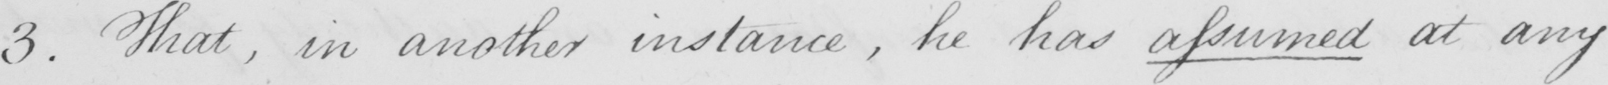What does this handwritten line say? 3 . That , in another instance , he has assumed at any 